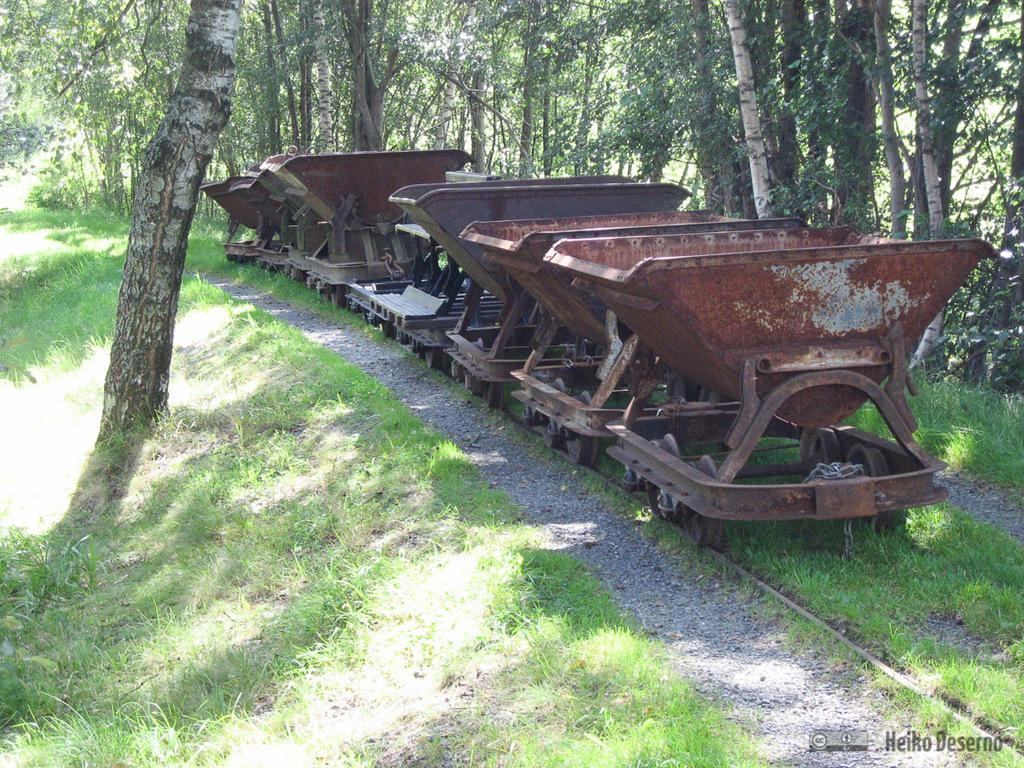What type of vegetation is at the bottom of the image? There is grass at the bottom of the image. What type of objects are in the middle of the image? There are iron objects in the middle of the image. What can be seen in the background of the image? There are trees in the background of the image. What type of picture is hanging on the tree in the image? There is no picture hanging on a tree in the image; it only features grass, iron objects, and trees. Can you hear the turkey gobbling in the image? There is no turkey present in the image, so it is not possible to hear any gobbling. 